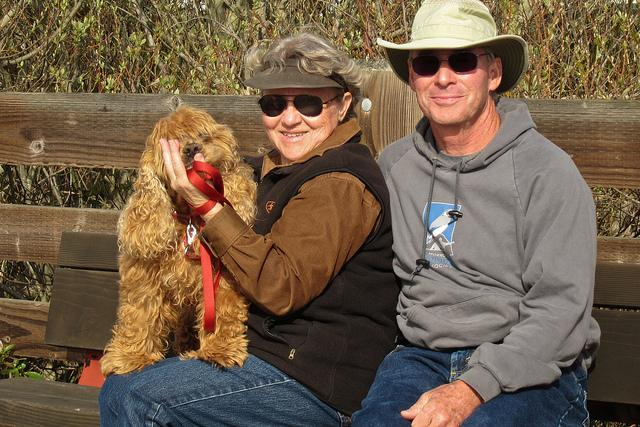What do both people have on? Please explain your reasoning. sunglasses. The man and woman are both sitting in the sun. 